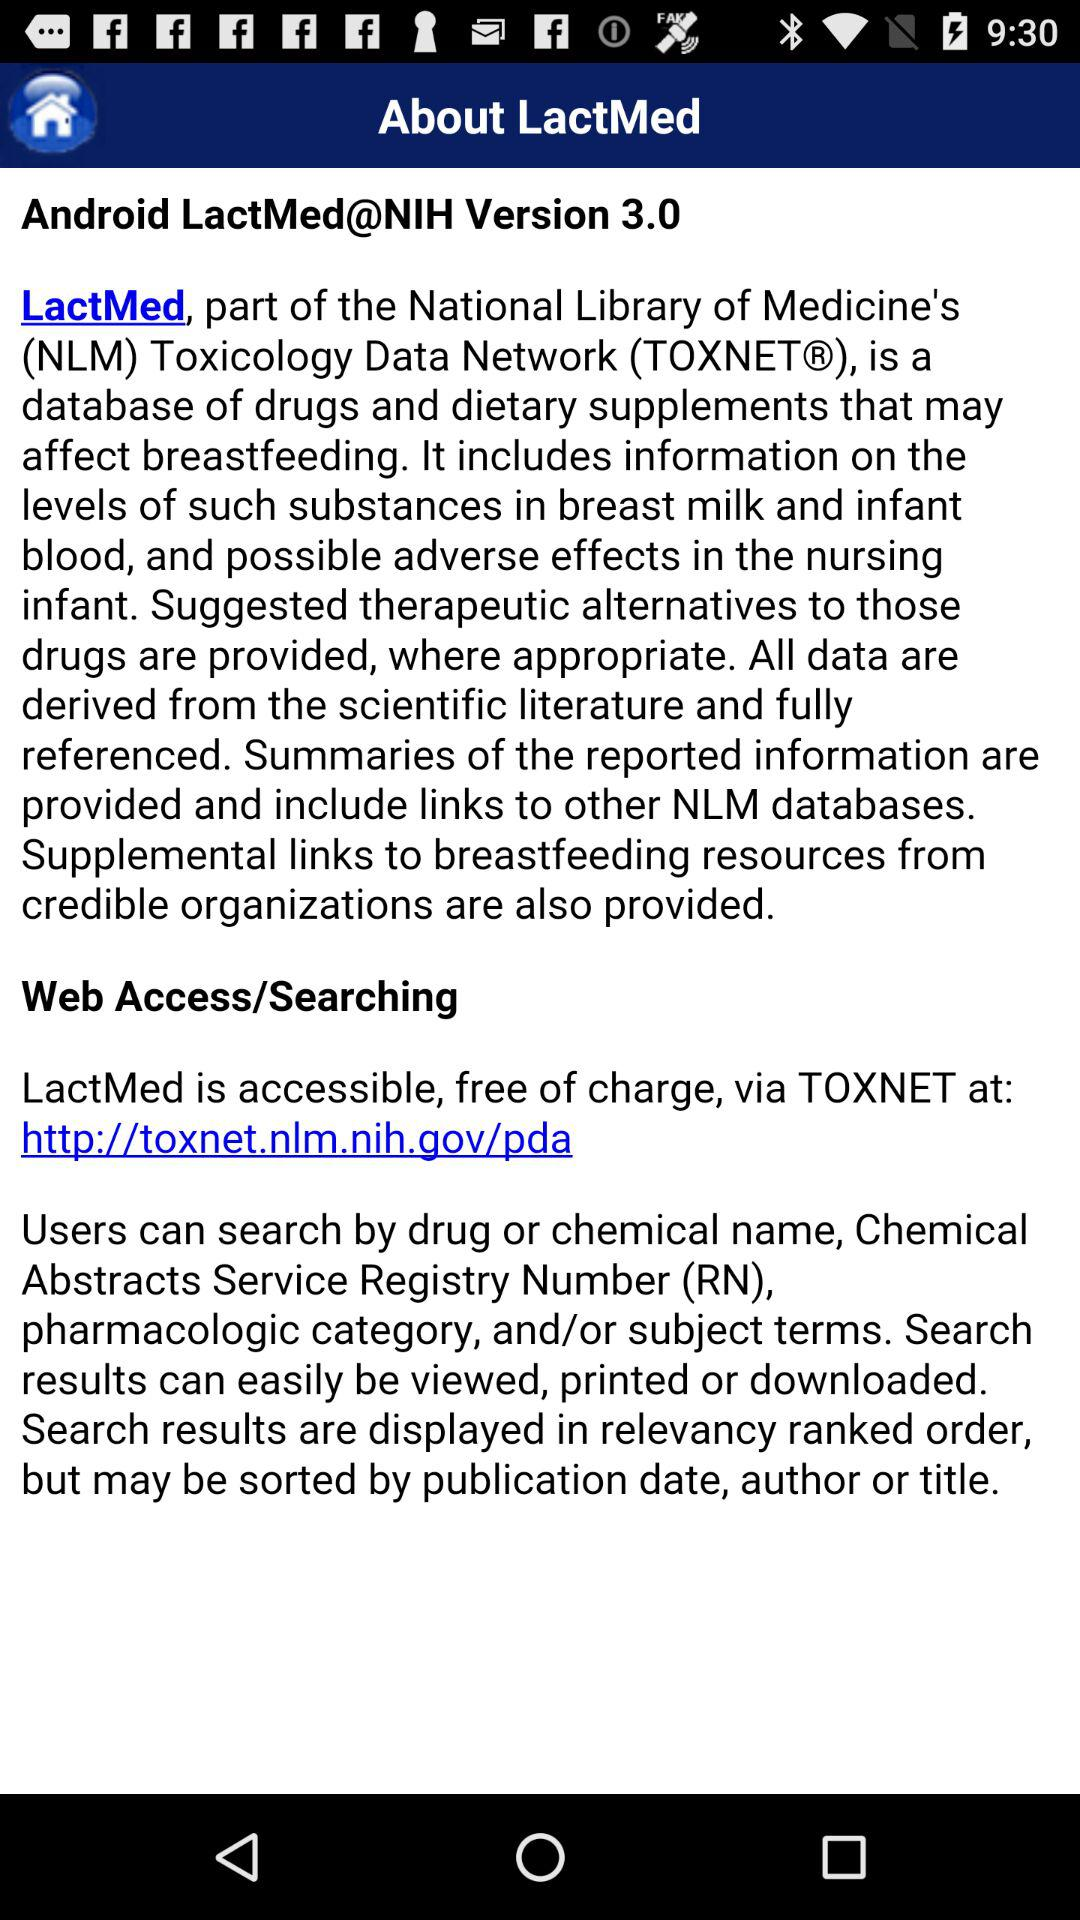What is the version of the application? The version of the application is 3.0. 